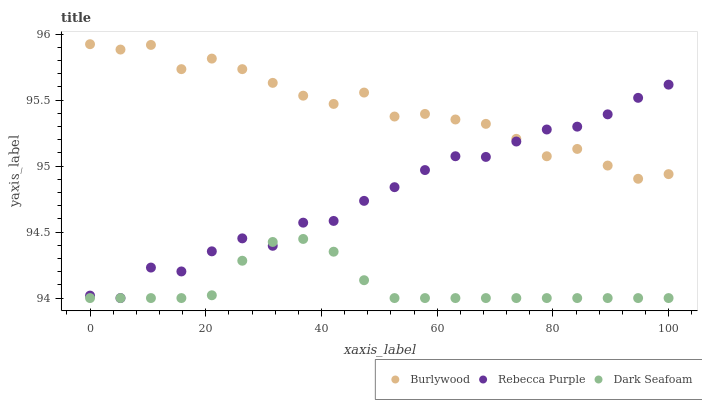Does Dark Seafoam have the minimum area under the curve?
Answer yes or no. Yes. Does Burlywood have the maximum area under the curve?
Answer yes or no. Yes. Does Rebecca Purple have the minimum area under the curve?
Answer yes or no. No. Does Rebecca Purple have the maximum area under the curve?
Answer yes or no. No. Is Dark Seafoam the smoothest?
Answer yes or no. Yes. Is Burlywood the roughest?
Answer yes or no. Yes. Is Rebecca Purple the smoothest?
Answer yes or no. No. Is Rebecca Purple the roughest?
Answer yes or no. No. Does Dark Seafoam have the lowest value?
Answer yes or no. Yes. Does Burlywood have the highest value?
Answer yes or no. Yes. Does Rebecca Purple have the highest value?
Answer yes or no. No. Is Dark Seafoam less than Burlywood?
Answer yes or no. Yes. Is Burlywood greater than Dark Seafoam?
Answer yes or no. Yes. Does Rebecca Purple intersect Burlywood?
Answer yes or no. Yes. Is Rebecca Purple less than Burlywood?
Answer yes or no. No. Is Rebecca Purple greater than Burlywood?
Answer yes or no. No. Does Dark Seafoam intersect Burlywood?
Answer yes or no. No. 